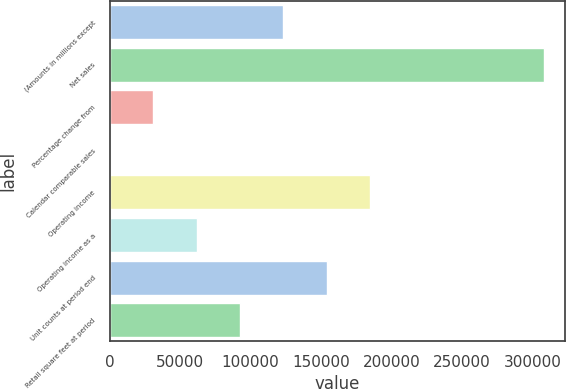Convert chart to OTSL. <chart><loc_0><loc_0><loc_500><loc_500><bar_chart><fcel>(Amounts in millions except<fcel>Net sales<fcel>Percentage change from<fcel>Calendar comparable sales<fcel>Operating income<fcel>Operating income as a<fcel>Unit counts at period end<fcel>Retail square feet at period<nl><fcel>123134<fcel>307833<fcel>30784.7<fcel>1.6<fcel>184700<fcel>61567.9<fcel>153917<fcel>92351<nl></chart> 